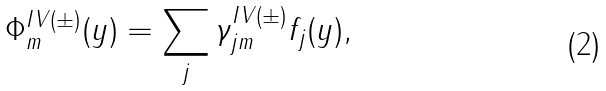<formula> <loc_0><loc_0><loc_500><loc_500>\Phi _ { m } ^ { I V ( \pm ) } ( y ) = \sum _ { j } \gamma _ { j m } ^ { I V ( \pm ) } f _ { j } ( y ) ,</formula> 